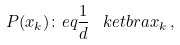Convert formula to latex. <formula><loc_0><loc_0><loc_500><loc_500>P ( x _ { k } ) \colon e q \frac { 1 } { d } \, \ k e t b r a { x _ { k } } \, ,</formula> 